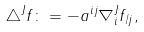<formula> <loc_0><loc_0><loc_500><loc_500>\triangle ^ { J } f \colon = - a ^ { i j } \nabla ^ { J } _ { i } f _ { / j } ,</formula> 